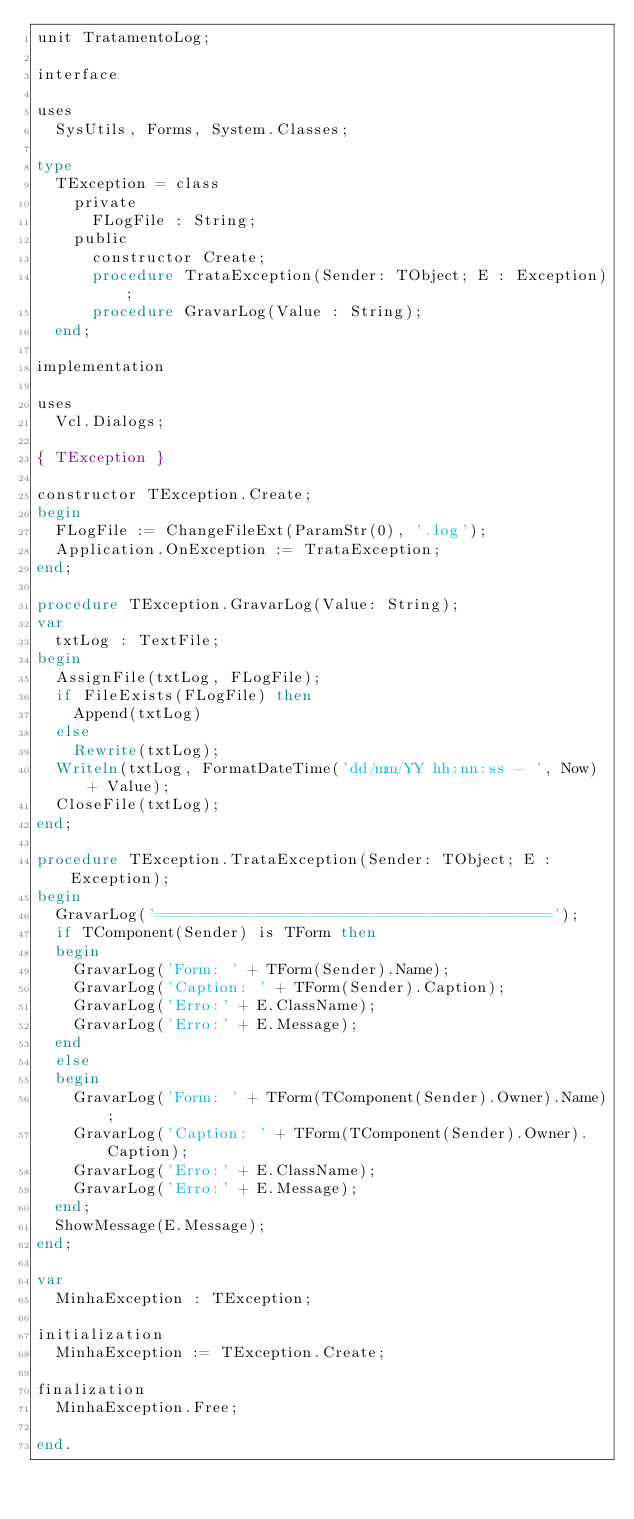Convert code to text. <code><loc_0><loc_0><loc_500><loc_500><_Pascal_>unit TratamentoLog;

interface

uses
  SysUtils, Forms, System.Classes;

type
  TException = class
    private
      FLogFile : String;
    public
      constructor Create;
      procedure TrataException(Sender: TObject; E : Exception);
      procedure GravarLog(Value : String);
  end;

implementation

uses
  Vcl.Dialogs;

{ TException }

constructor TException.Create;
begin
  FLogFile := ChangeFileExt(ParamStr(0), '.log');
  Application.OnException := TrataException;
end;

procedure TException.GravarLog(Value: String);
var
  txtLog : TextFile;
begin
  AssignFile(txtLog, FLogFile);
  if FileExists(FLogFile) then
    Append(txtLog)
  else
    Rewrite(txtLog);
  Writeln(txtLog, FormatDateTime('dd/mm/YY hh:nn:ss - ', Now) + Value);
  CloseFile(txtLog);
end;

procedure TException.TrataException(Sender: TObject; E : Exception);
begin
  GravarLog('===========================================');
  if TComponent(Sender) is TForm then
  begin
    GravarLog('Form: ' + TForm(Sender).Name);
    GravarLog('Caption: ' + TForm(Sender).Caption);
    GravarLog('Erro:' + E.ClassName);
    GravarLog('Erro:' + E.Message);
  end
  else
  begin
    GravarLog('Form: ' + TForm(TComponent(Sender).Owner).Name);
    GravarLog('Caption: ' + TForm(TComponent(Sender).Owner).Caption);
    GravarLog('Erro:' + E.ClassName);
    GravarLog('Erro:' + E.Message);
  end;
  ShowMessage(E.Message);
end;

var
  MinhaException : TException;

initialization
  MinhaException := TException.Create;

finalization
  MinhaException.Free;

end.
</code> 